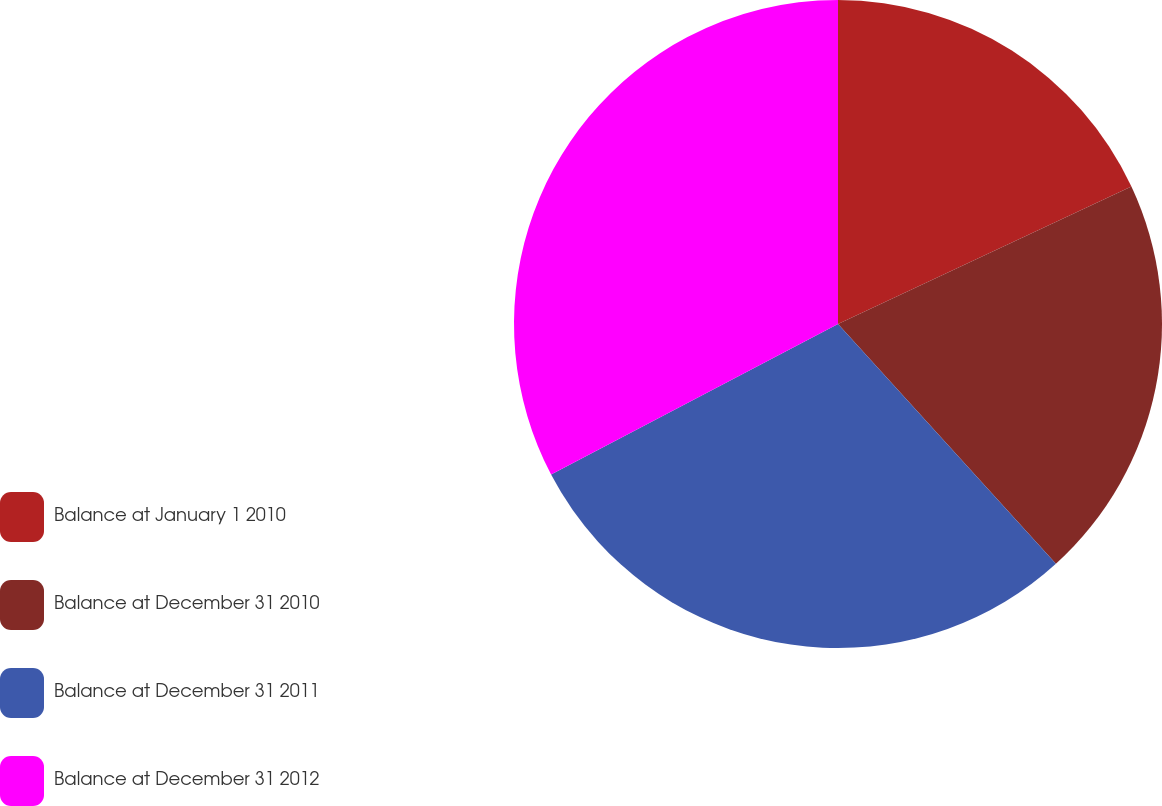Convert chart. <chart><loc_0><loc_0><loc_500><loc_500><pie_chart><fcel>Balance at January 1 2010<fcel>Balance at December 31 2010<fcel>Balance at December 31 2011<fcel>Balance at December 31 2012<nl><fcel>18.03%<fcel>20.23%<fcel>29.05%<fcel>32.69%<nl></chart> 